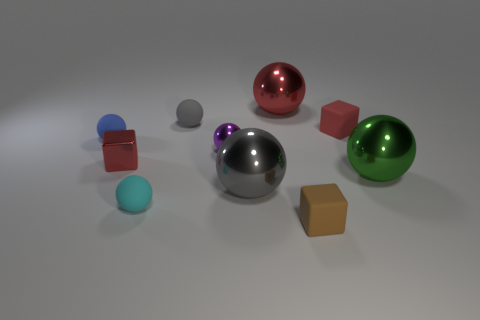What shape is the red rubber thing?
Make the answer very short. Cube. There is a rubber object that is the same color as the shiny block; what is its shape?
Provide a short and direct response. Cube. What number of purple balls are the same material as the tiny cyan sphere?
Offer a terse response. 0. The metallic cube has what color?
Ensure brevity in your answer.  Red. There is a gray thing that is to the right of the purple ball; does it have the same shape as the red metallic object behind the red matte cube?
Your answer should be very brief. Yes. There is a shiny thing left of the small gray matte sphere; what is its color?
Give a very brief answer. Red. Is the number of small metallic cubes that are right of the tiny red rubber cube less than the number of large gray spheres that are right of the brown block?
Make the answer very short. No. How many other things are there of the same material as the purple sphere?
Offer a terse response. 4. Do the large red sphere and the brown thing have the same material?
Your response must be concise. No. How many other things are the same size as the brown rubber object?
Offer a very short reply. 6. 